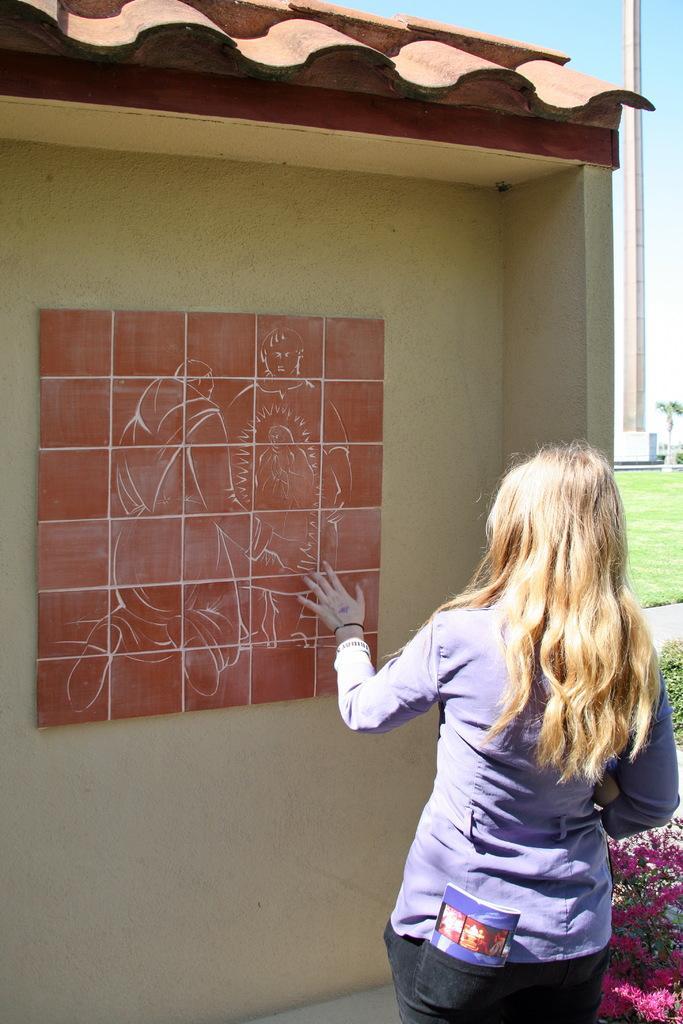Describe this image in one or two sentences. In her pocket there is a book. She is looking at the picture. Right side of the image we can see pillar, tree, grass and plants with flowers. 